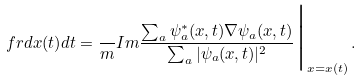<formula> <loc_0><loc_0><loc_500><loc_500>\ f r { d { x } ( t ) } { d t } = \frac { } { m } { I m } \frac { \sum _ { a } \psi ^ { * } _ { a } ( { x } , t ) { \nabla } \psi _ { a } ( { x } , t ) } { \sum _ { a } | \psi _ { a } ( { x } , t ) | ^ { 2 } } \Big | _ { { x } = { x } ( t ) } \, .</formula> 